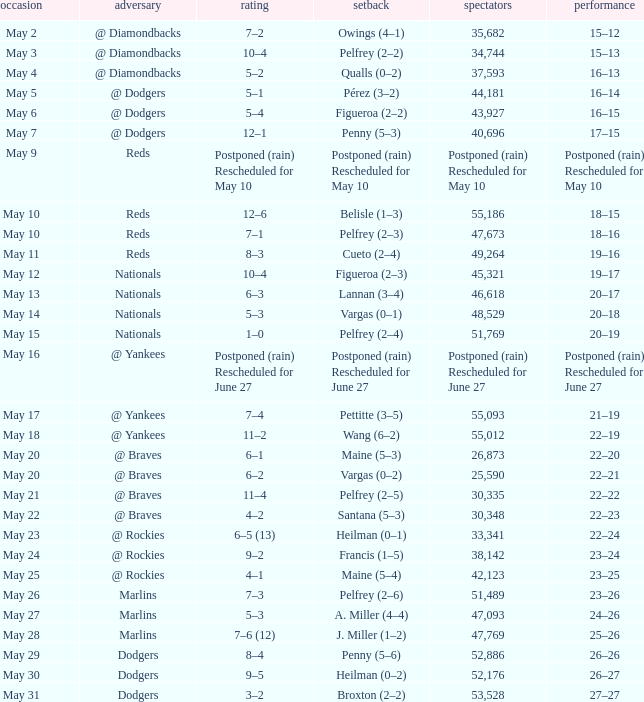Opponent of @ braves, and a Loss of pelfrey (2–5) had what score? 11–4. 